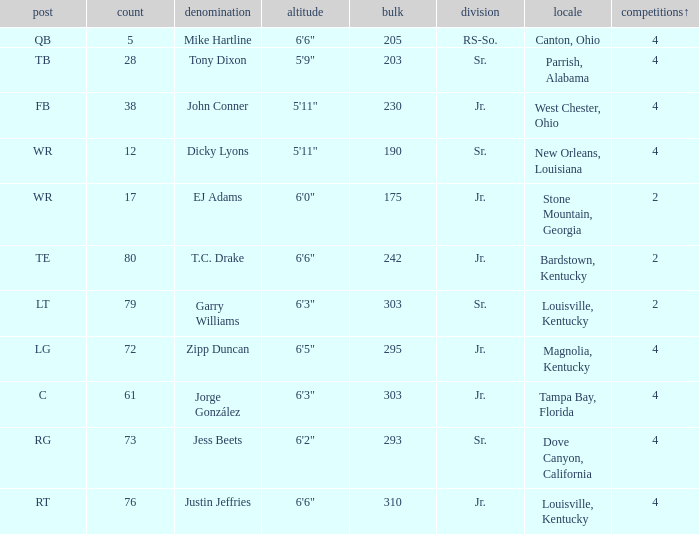Which Class has a Weight of 203? Sr. 